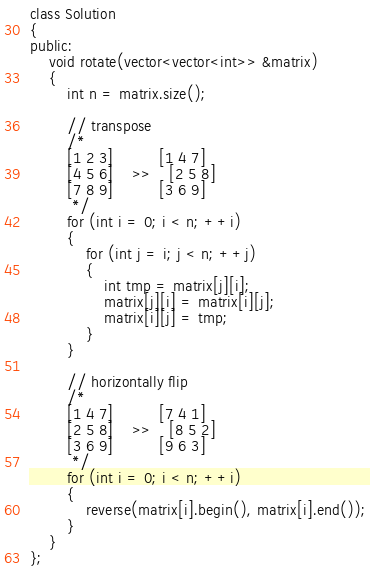Convert code to text. <code><loc_0><loc_0><loc_500><loc_500><_C++_>class Solution
{
public:
    void rotate(vector<vector<int>> &matrix)
    {
        int n = matrix.size();

        // transpose
        /*
        [1 2 3]          [1 4 7]
        [4 5 6]    >>    [2 5 8]
        [7 8 9]          [3 6 9]
         */
        for (int i = 0; i < n; ++i)
        {
            for (int j = i; j < n; ++j)
            {
                int tmp = matrix[j][i];
                matrix[j][i] = matrix[i][j];
                matrix[i][j] = tmp;
            }
        }

        // horizontally flip
        /*
        [1 4 7]          [7 4 1]
        [2 5 8]    >>    [8 5 2]
        [3 6 9]          [9 6 3]
         */
        for (int i = 0; i < n; ++i)
        {
            reverse(matrix[i].begin(), matrix[i].end());
        }
    }
};</code> 